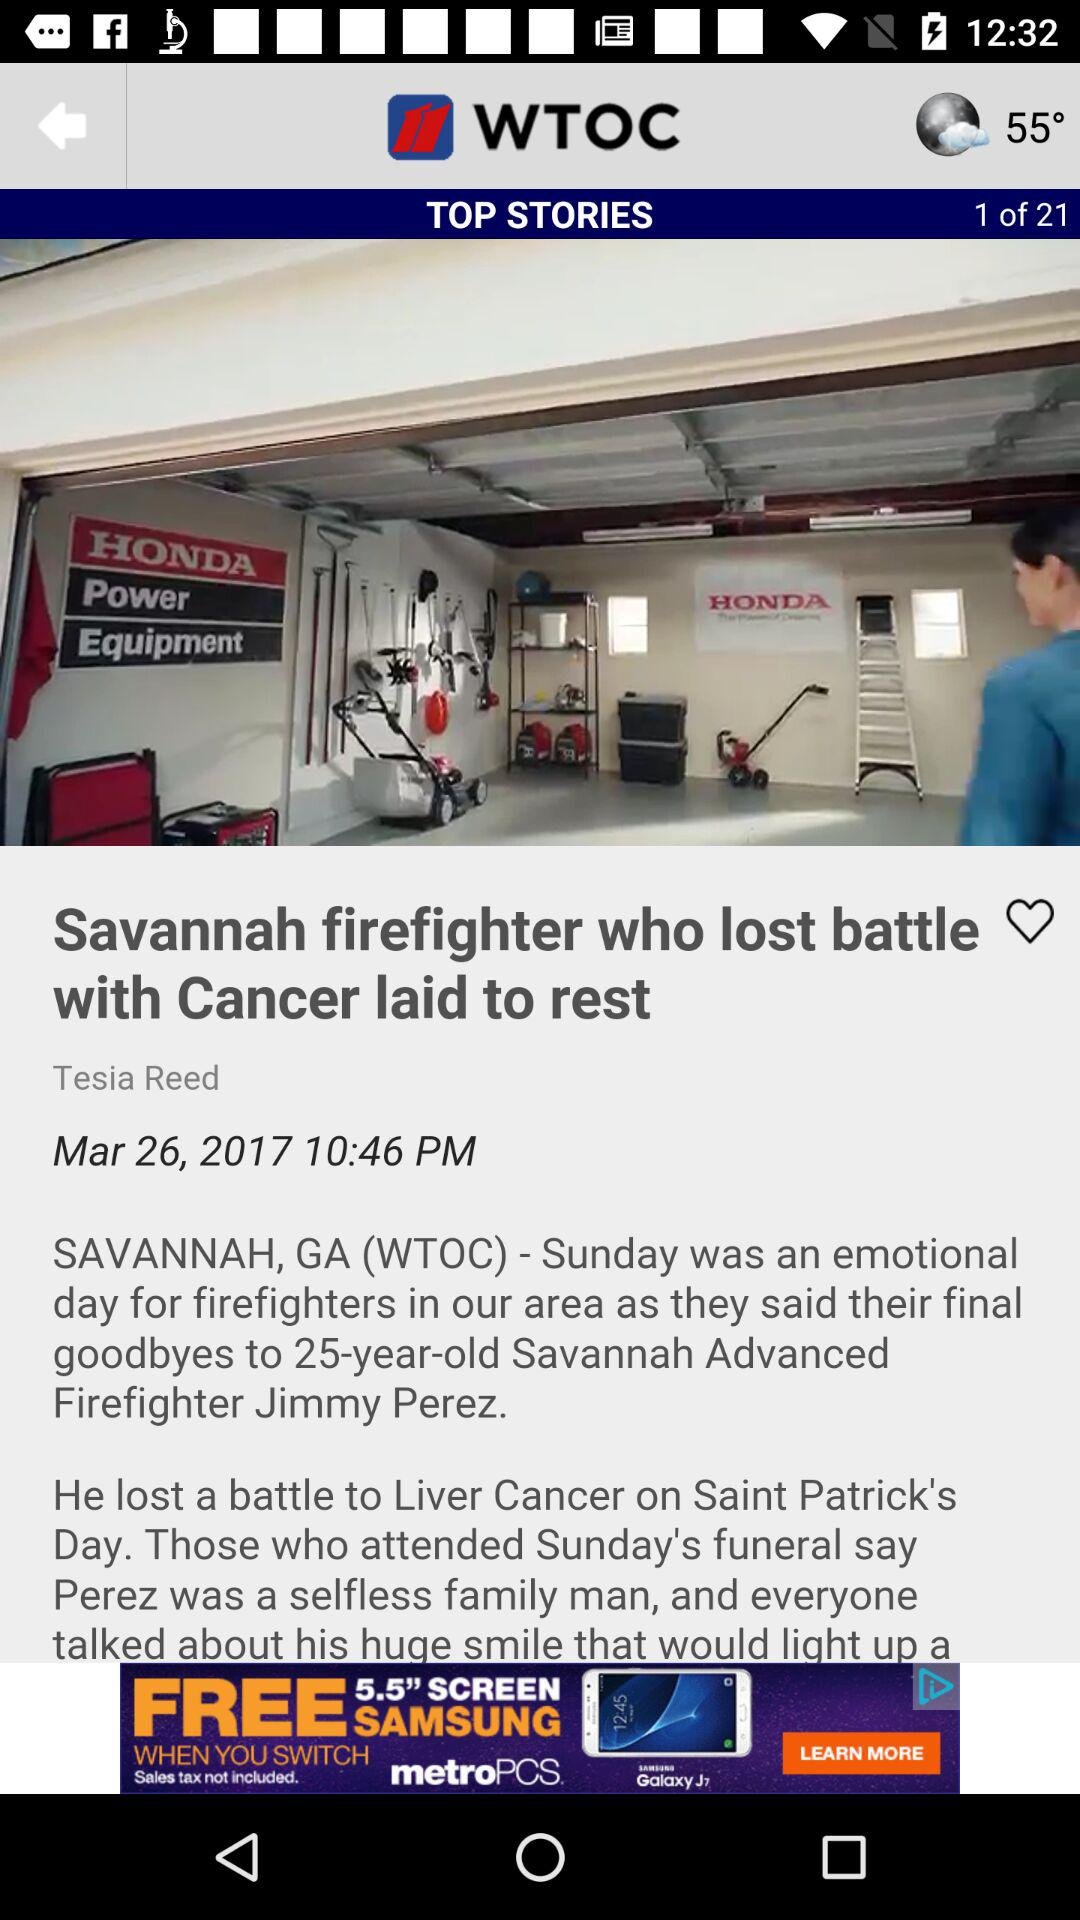What is the headline of the article? The headline is "Savannah firefighter who lost battle with Cancer laid to rest". 